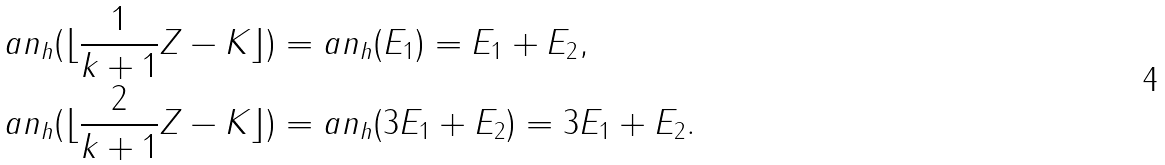<formula> <loc_0><loc_0><loc_500><loc_500>& a n _ { h } ( \lfloor \frac { 1 } { k + 1 } Z - K \rfloor ) = a n _ { h } ( E _ { 1 } ) = E _ { 1 } + E _ { 2 } , \\ & a n _ { h } ( \lfloor \frac { 2 } { k + 1 } Z - K \rfloor ) = a n _ { h } ( 3 E _ { 1 } + E _ { 2 } ) = 3 E _ { 1 } + E _ { 2 } .</formula> 